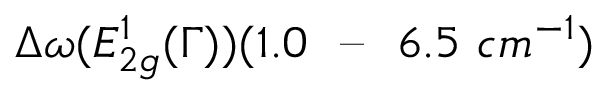<formula> <loc_0><loc_0><loc_500><loc_500>\Delta \omega ( E _ { 2 g } ^ { 1 } ( \Gamma ) ) ( 1 . 0 \ - - \ 6 . 5 \ c m ^ { - 1 } )</formula> 